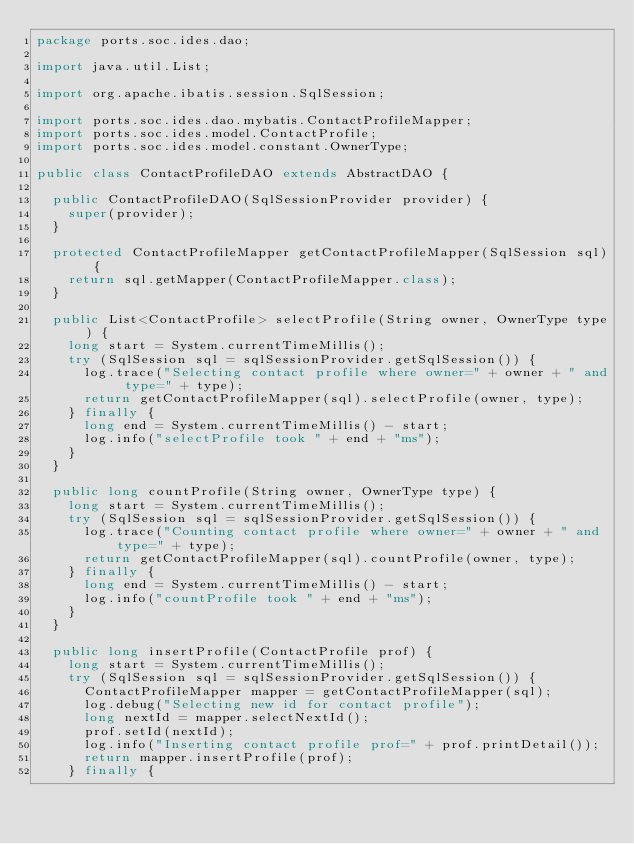Convert code to text. <code><loc_0><loc_0><loc_500><loc_500><_Java_>package ports.soc.ides.dao;

import java.util.List;

import org.apache.ibatis.session.SqlSession;

import ports.soc.ides.dao.mybatis.ContactProfileMapper;
import ports.soc.ides.model.ContactProfile;
import ports.soc.ides.model.constant.OwnerType;

public class ContactProfileDAO extends AbstractDAO {

	public ContactProfileDAO(SqlSessionProvider provider) {
		super(provider);
	}

	protected ContactProfileMapper getContactProfileMapper(SqlSession sql) {
		return sql.getMapper(ContactProfileMapper.class);
	}

	public List<ContactProfile> selectProfile(String owner, OwnerType type) {
		long start = System.currentTimeMillis();
		try (SqlSession sql = sqlSessionProvider.getSqlSession()) {
			log.trace("Selecting contact profile where owner=" + owner + " and type=" + type);
			return getContactProfileMapper(sql).selectProfile(owner, type);
		} finally {
			long end = System.currentTimeMillis() - start;
			log.info("selectProfile took " + end + "ms");
		}
	}

	public long countProfile(String owner, OwnerType type) {
		long start = System.currentTimeMillis();
		try (SqlSession sql = sqlSessionProvider.getSqlSession()) {
			log.trace("Counting contact profile where owner=" + owner + " and type=" + type);
			return getContactProfileMapper(sql).countProfile(owner, type);
		} finally {
			long end = System.currentTimeMillis() - start;
			log.info("countProfile took " + end + "ms");
		}
	}

	public long insertProfile(ContactProfile prof) {
		long start = System.currentTimeMillis();
		try (SqlSession sql = sqlSessionProvider.getSqlSession()) {
			ContactProfileMapper mapper = getContactProfileMapper(sql);
			log.debug("Selecting new id for contact profile");
			long nextId = mapper.selectNextId();
			prof.setId(nextId);
			log.info("Inserting contact profile prof=" + prof.printDetail());
			return mapper.insertProfile(prof);
		} finally {</code> 